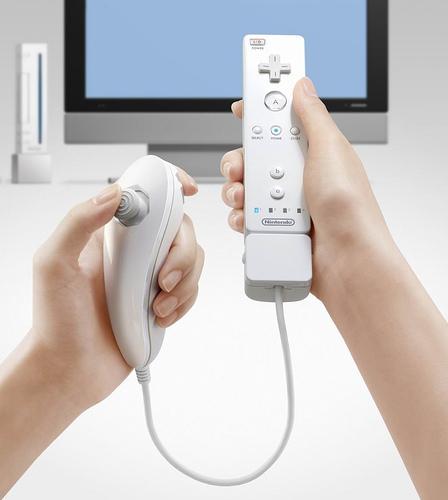What color is the controller?
Keep it brief. White. What video console is this controller used for?
Give a very brief answer. Wii. Do you need both hands to use the controller?
Be succinct. Yes. 